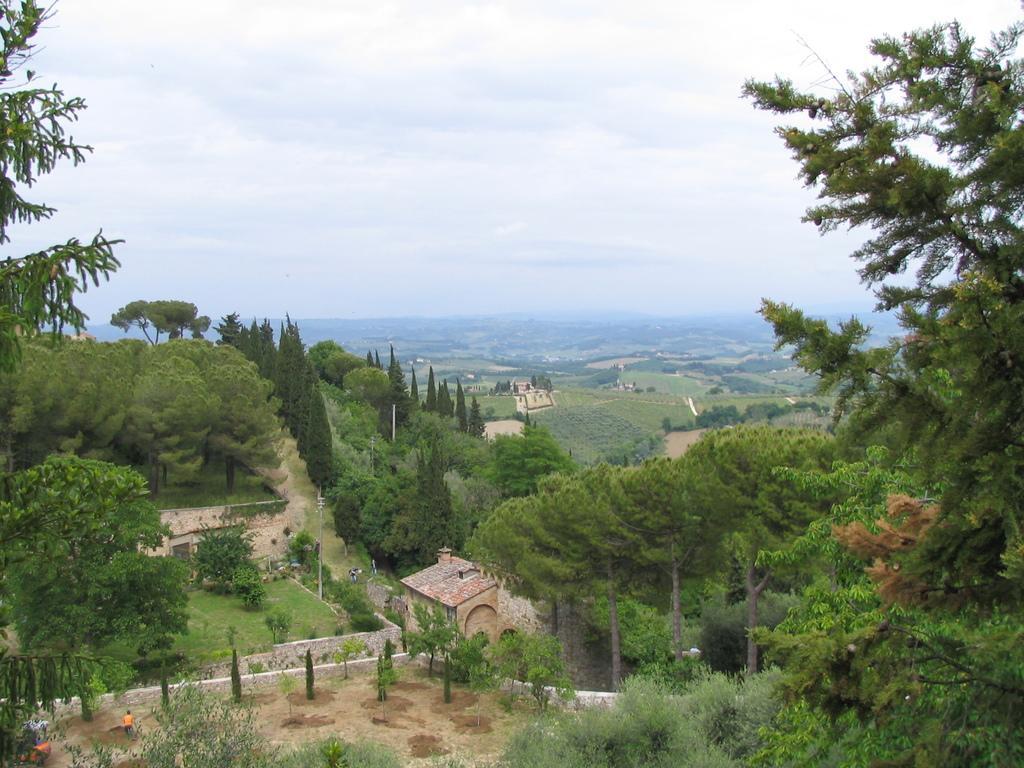Can you describe this image briefly? In this image we can see houses, plants, trees, there is a person, there are poles, also we can see the sky. 